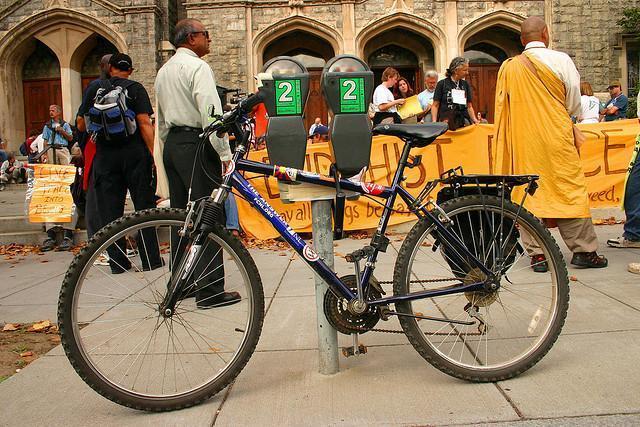How many parking meters are there?
Give a very brief answer. 2. How many people are there?
Give a very brief answer. 5. 